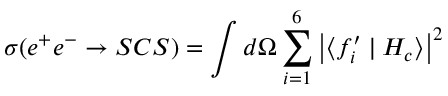<formula> <loc_0><loc_0><loc_500><loc_500>\sigma ( e ^ { + } e ^ { - } \rightarrow S C S ) = \int d \Omega \sum _ { i = 1 } ^ { 6 } \left | \langle f _ { i } ^ { \prime } | H _ { c } \rangle \right | ^ { 2 }</formula> 